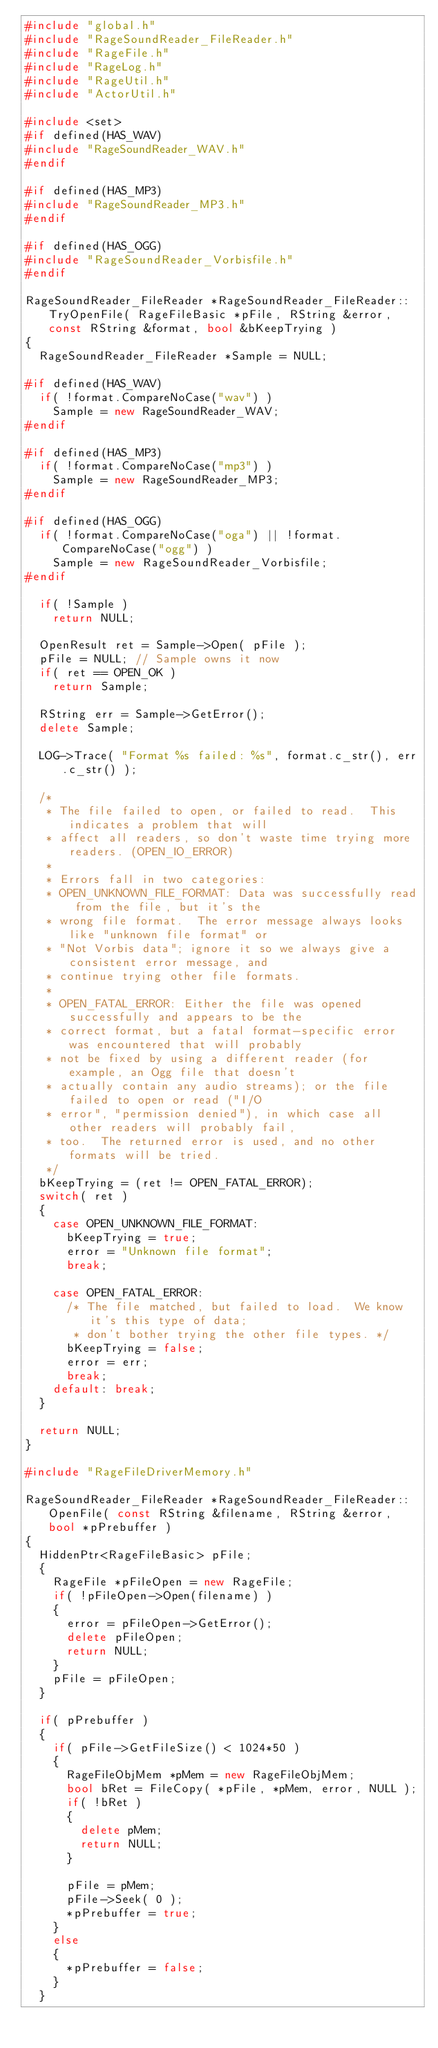<code> <loc_0><loc_0><loc_500><loc_500><_C++_>#include "global.h"
#include "RageSoundReader_FileReader.h"
#include "RageFile.h"
#include "RageLog.h"
#include "RageUtil.h"
#include "ActorUtil.h"

#include <set>
#if defined(HAS_WAV)
#include "RageSoundReader_WAV.h"
#endif

#if defined(HAS_MP3)
#include "RageSoundReader_MP3.h"
#endif

#if defined(HAS_OGG)
#include "RageSoundReader_Vorbisfile.h"
#endif

RageSoundReader_FileReader *RageSoundReader_FileReader::TryOpenFile( RageFileBasic *pFile, RString &error, const RString &format, bool &bKeepTrying )
{
	RageSoundReader_FileReader *Sample = NULL;

#if defined(HAS_WAV)
	if( !format.CompareNoCase("wav") )
		Sample = new RageSoundReader_WAV;
#endif

#if defined(HAS_MP3)
	if( !format.CompareNoCase("mp3") )
		Sample = new RageSoundReader_MP3;
#endif

#if defined(HAS_OGG)
	if( !format.CompareNoCase("oga") || !format.CompareNoCase("ogg") )
		Sample = new RageSoundReader_Vorbisfile;
#endif

	if( !Sample )
		return NULL;

	OpenResult ret = Sample->Open( pFile );
	pFile = NULL; // Sample owns it now
	if( ret == OPEN_OK )
		return Sample;

	RString err = Sample->GetError();
	delete Sample;

	LOG->Trace( "Format %s failed: %s", format.c_str(), err.c_str() );

	/*
	 * The file failed to open, or failed to read.  This indicates a problem that will
	 * affect all readers, so don't waste time trying more readers. (OPEN_IO_ERROR)
	 *
	 * Errors fall in two categories:
	 * OPEN_UNKNOWN_FILE_FORMAT: Data was successfully read from the file, but it's the
	 * wrong file format.  The error message always looks like "unknown file format" or
	 * "Not Vorbis data"; ignore it so we always give a consistent error message, and
	 * continue trying other file formats.
	 *
	 * OPEN_FATAL_ERROR: Either the file was opened successfully and appears to be the
	 * correct format, but a fatal format-specific error was encountered that will probably
	 * not be fixed by using a different reader (for example, an Ogg file that doesn't
	 * actually contain any audio streams); or the file failed to open or read ("I/O
	 * error", "permission denied"), in which case all other readers will probably fail,
	 * too.  The returned error is used, and no other formats will be tried.
	 */
	bKeepTrying = (ret != OPEN_FATAL_ERROR);
	switch( ret )
	{
		case OPEN_UNKNOWN_FILE_FORMAT:
			bKeepTrying = true;
			error = "Unknown file format";
			break;

		case OPEN_FATAL_ERROR:
			/* The file matched, but failed to load.  We know it's this type of data;
			 * don't bother trying the other file types. */
			bKeepTrying = false;
			error = err;
			break;
		default: break;
	}

	return NULL;
}

#include "RageFileDriverMemory.h"

RageSoundReader_FileReader *RageSoundReader_FileReader::OpenFile( const RString &filename, RString &error, bool *pPrebuffer )
{
	HiddenPtr<RageFileBasic> pFile;
	{
		RageFile *pFileOpen = new RageFile;
		if( !pFileOpen->Open(filename) )
		{
			error = pFileOpen->GetError();
			delete pFileOpen;
			return NULL;
		}
		pFile = pFileOpen;
	}

	if( pPrebuffer )
	{
		if( pFile->GetFileSize() < 1024*50 )
		{
			RageFileObjMem *pMem = new RageFileObjMem;
			bool bRet = FileCopy( *pFile, *pMem, error, NULL );
			if( !bRet )
			{
				delete pMem;
				return NULL;
			}

			pFile = pMem;
			pFile->Seek( 0 );
			*pPrebuffer = true;
		}
		else
		{
			*pPrebuffer = false;
		}
	}</code> 